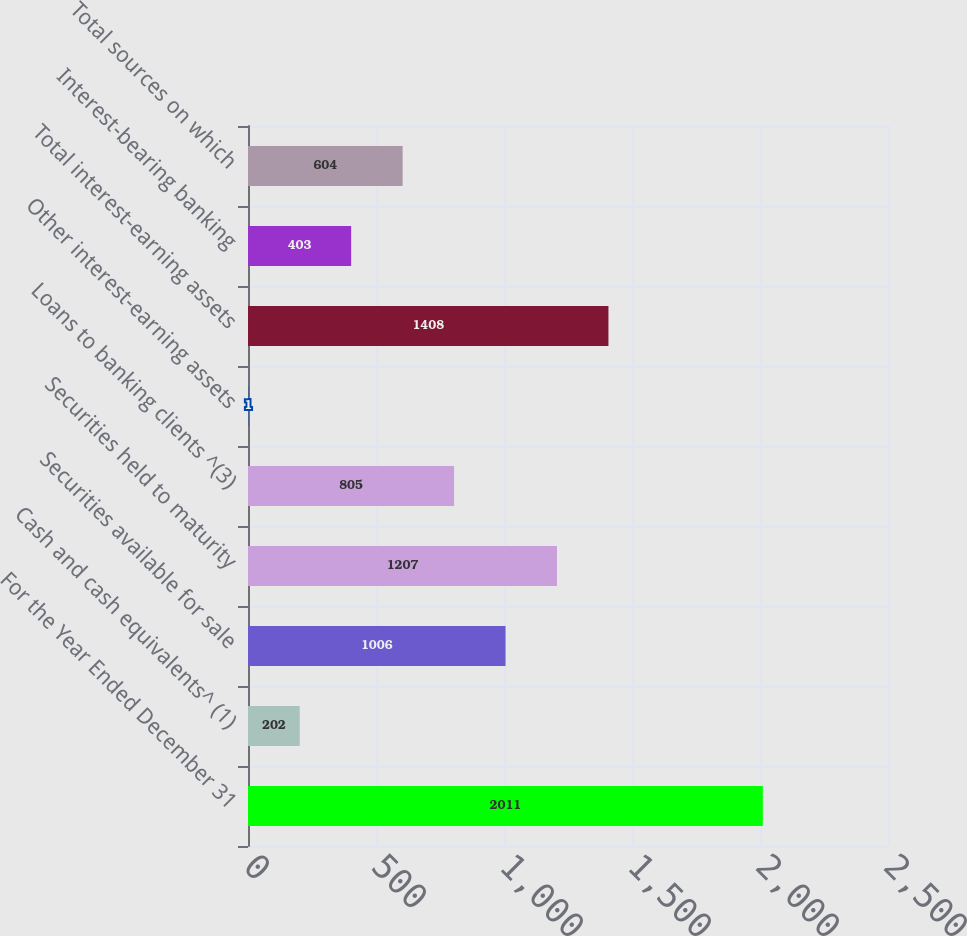Convert chart to OTSL. <chart><loc_0><loc_0><loc_500><loc_500><bar_chart><fcel>For the Year Ended December 31<fcel>Cash and cash equivalents^ (1)<fcel>Securities available for sale<fcel>Securities held to maturity<fcel>Loans to banking clients ^(3)<fcel>Other interest-earning assets<fcel>Total interest-earning assets<fcel>Interest-bearing banking<fcel>Total sources on which<nl><fcel>2011<fcel>202<fcel>1006<fcel>1207<fcel>805<fcel>1<fcel>1408<fcel>403<fcel>604<nl></chart> 